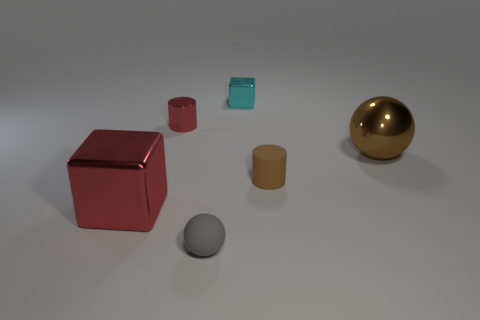Can you describe the different shapes and their colors in the image? Certainly! There's a red cube, a gold sphere, a grey sphere that's smaller in size, a brown cylinder, and a small cyan cube. Each object has a smooth surface suggesting they might be made of metal or plastic. 